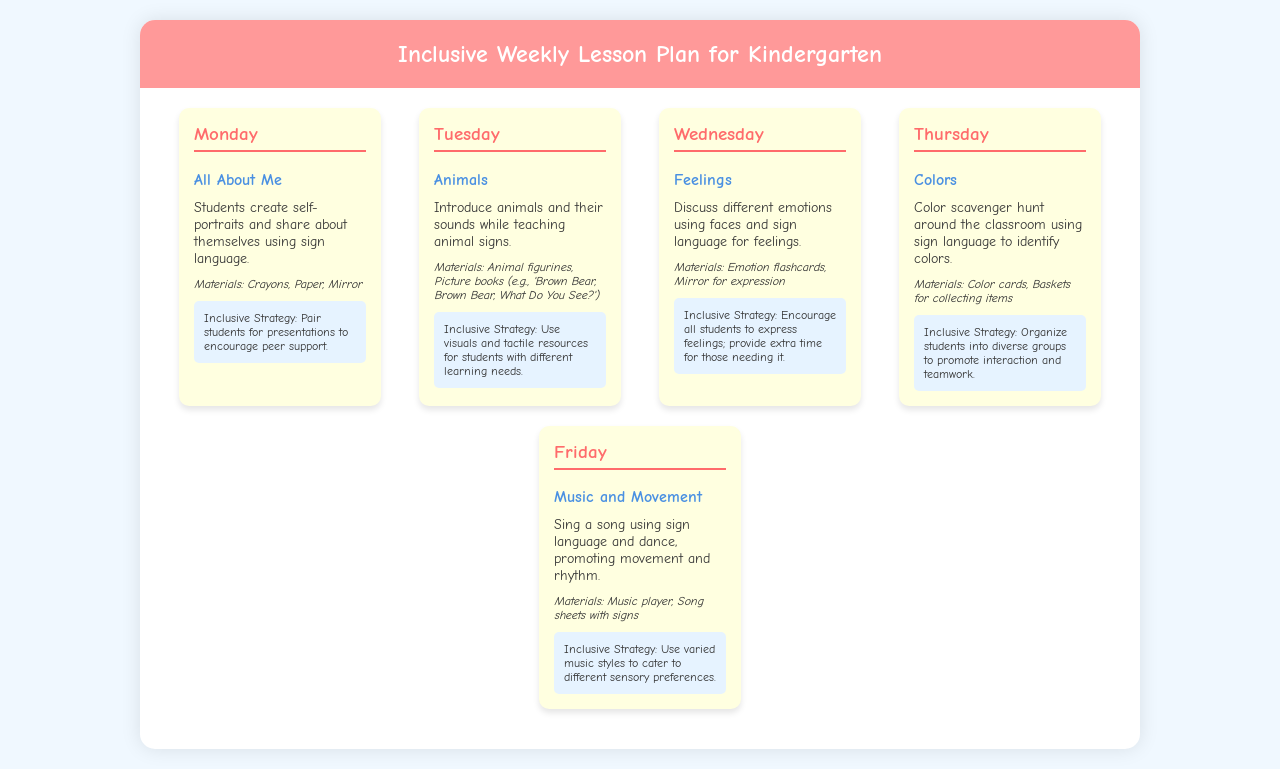What is the theme for Monday? The theme for Monday is "All About Me," as stated in the document.
Answer: All About Me Which day focuses on animals? The day dedicated to animals, as noted, is Tuesday.
Answer: Tuesday What type of materials are used for color activities? The materials listed for color activities include color cards and baskets for collecting items.
Answer: Color cards, Baskets for collecting items What inclusive strategy is used for the feelings discussion? The inclusive strategy for the feelings discussion encourages all students to express feelings and provides extra time for those needing it.
Answer: Encourage all students to express feelings; provide extra time for those needing it How many days are included in the lesson plan? The document outlines a lesson plan that includes five days.
Answer: Five What is the main activity for Friday? The main activity for Friday is singing a song using sign language and dance.
Answer: Sing a song using sign language and dance What materials are required for the animal activity? The materials needed for the animal activity are animal figurines and picture books, specifically "Brown Bear, Brown Bear, What Do You See?"
Answer: Animal figurines, Picture books (e.g., 'Brown Bear, Brown Bear, What Do You See?') What strategy is used on Thursday for inclusive teaching? The strategy for Thursday is to organize students into diverse groups to promote interaction and teamwork.
Answer: Organize students into diverse groups to promote interaction and teamwork 